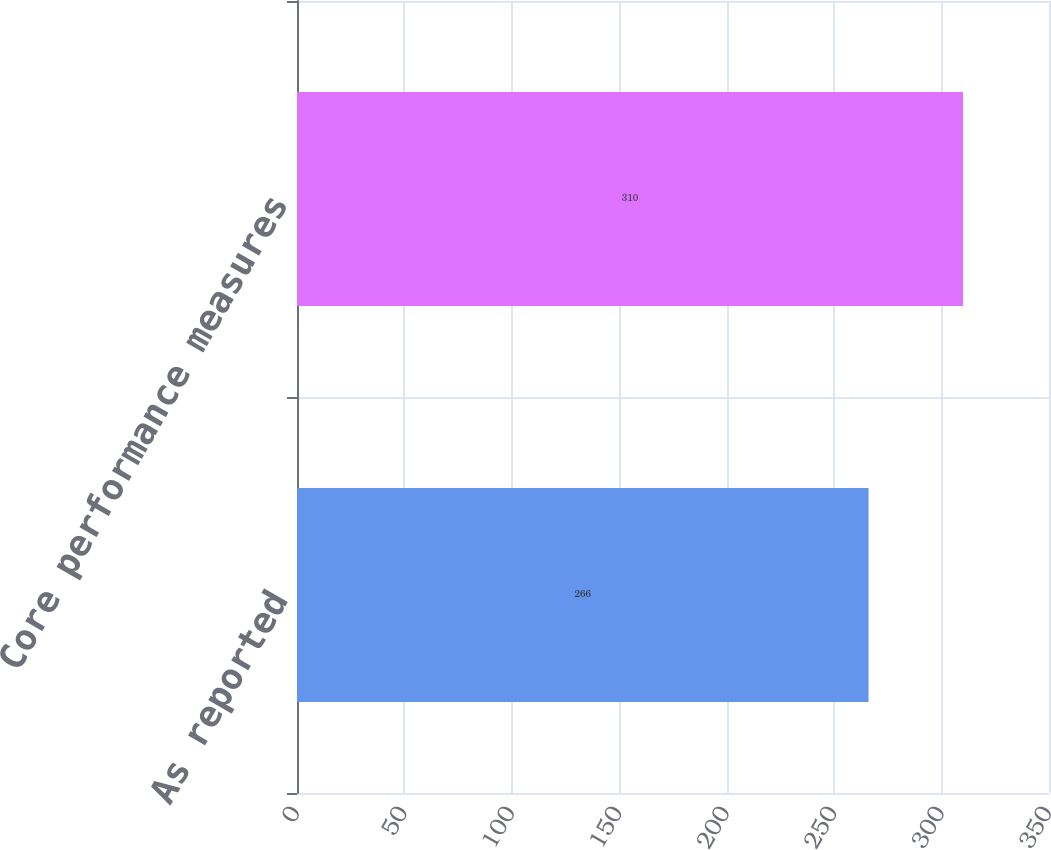<chart> <loc_0><loc_0><loc_500><loc_500><bar_chart><fcel>As reported<fcel>Core performance measures<nl><fcel>266<fcel>310<nl></chart> 